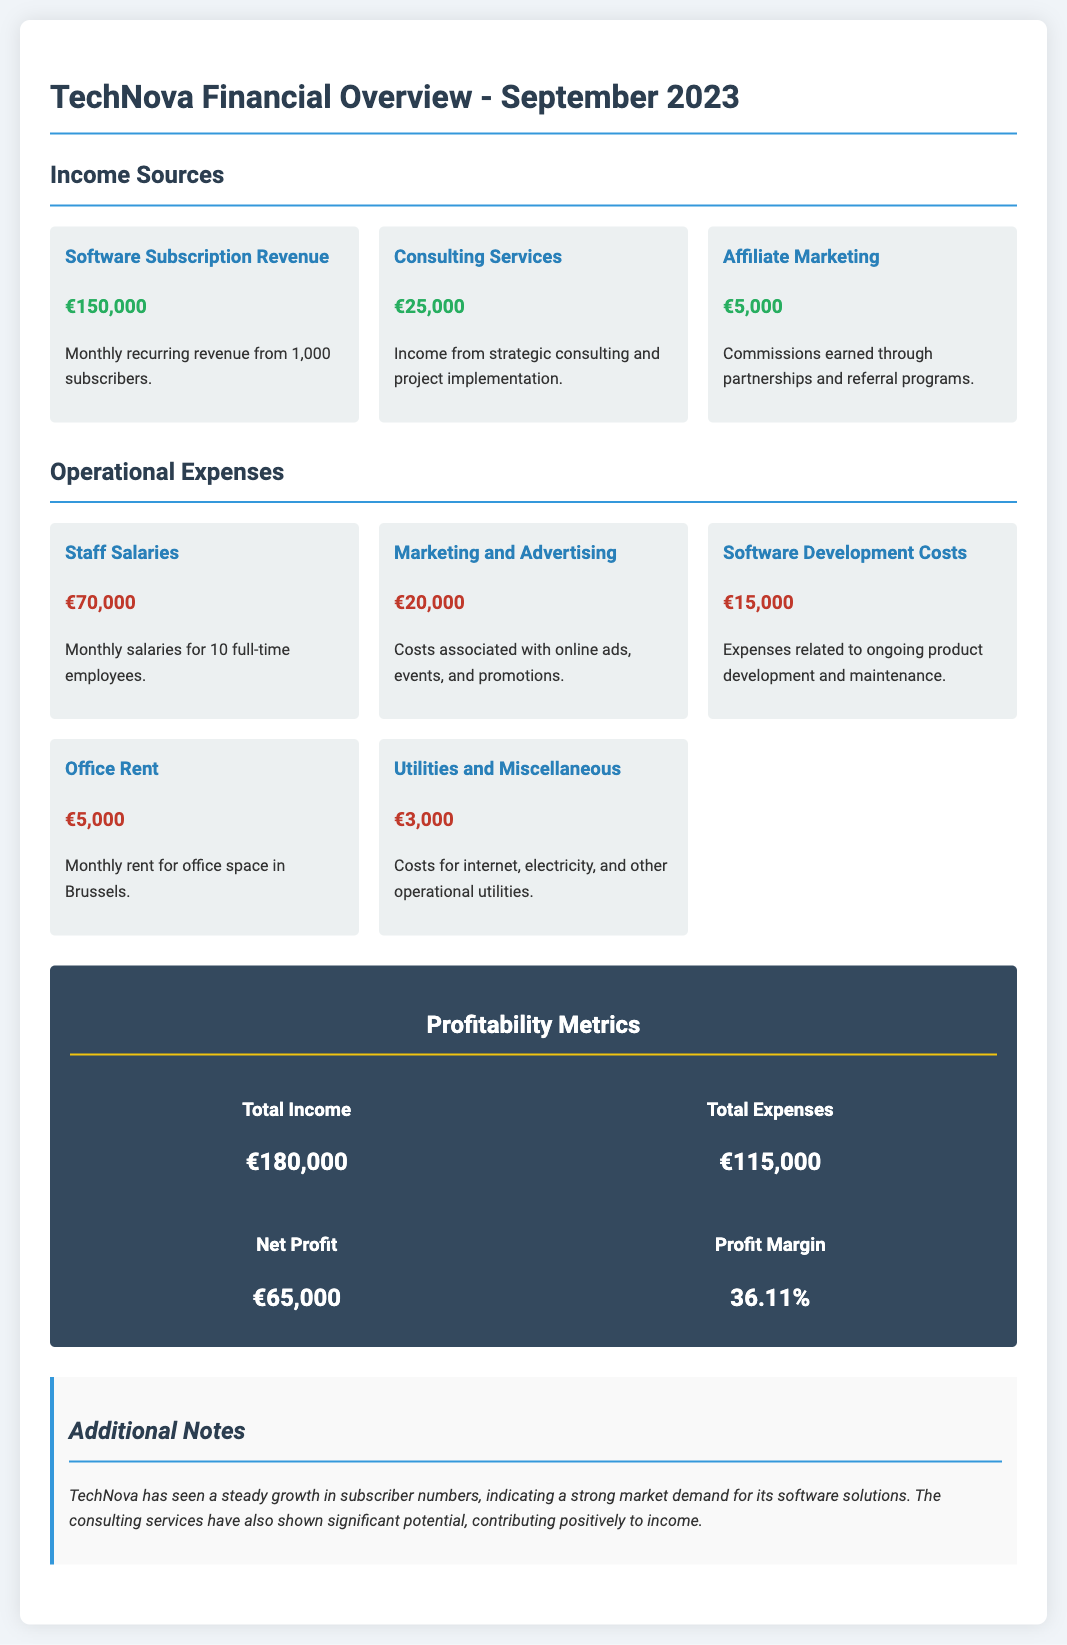What is the total income for September 2023? The total income is detailed in the profitability metrics section as €180,000.
Answer: €180,000 What are the software subscription revenues? The software subscription revenue is stated as monthly recurring revenue from subscribers, amounting to €150,000.
Answer: €150,000 How much was spent on staff salaries? Staff salaries are listed under operational expenses as €70,000.
Answer: €70,000 What is the net profit for TechNova? The net profit is provided in the profitability metrics section as €65,000.
Answer: €65,000 What percentage of profit margin does TechNova have? The profit margin is indicated in the profitability metrics section as 36.11%.
Answer: 36.11% Which income source generated the least revenue? The income source with the least revenue is affiliate marketing, which earned €5,000.
Answer: €5,000 What was the total amount spent on operational expenses? The total operational expenses are detailed in the profitability metrics section as €115,000.
Answer: €115,000 What is TechNova's primary service offering? TechNova's primary service offering is software subscription services.
Answer: Software subscription services How many full-time employees does TechNova have? The document states that TechNova has 10 full-time employees listed under staff salaries.
Answer: 10 